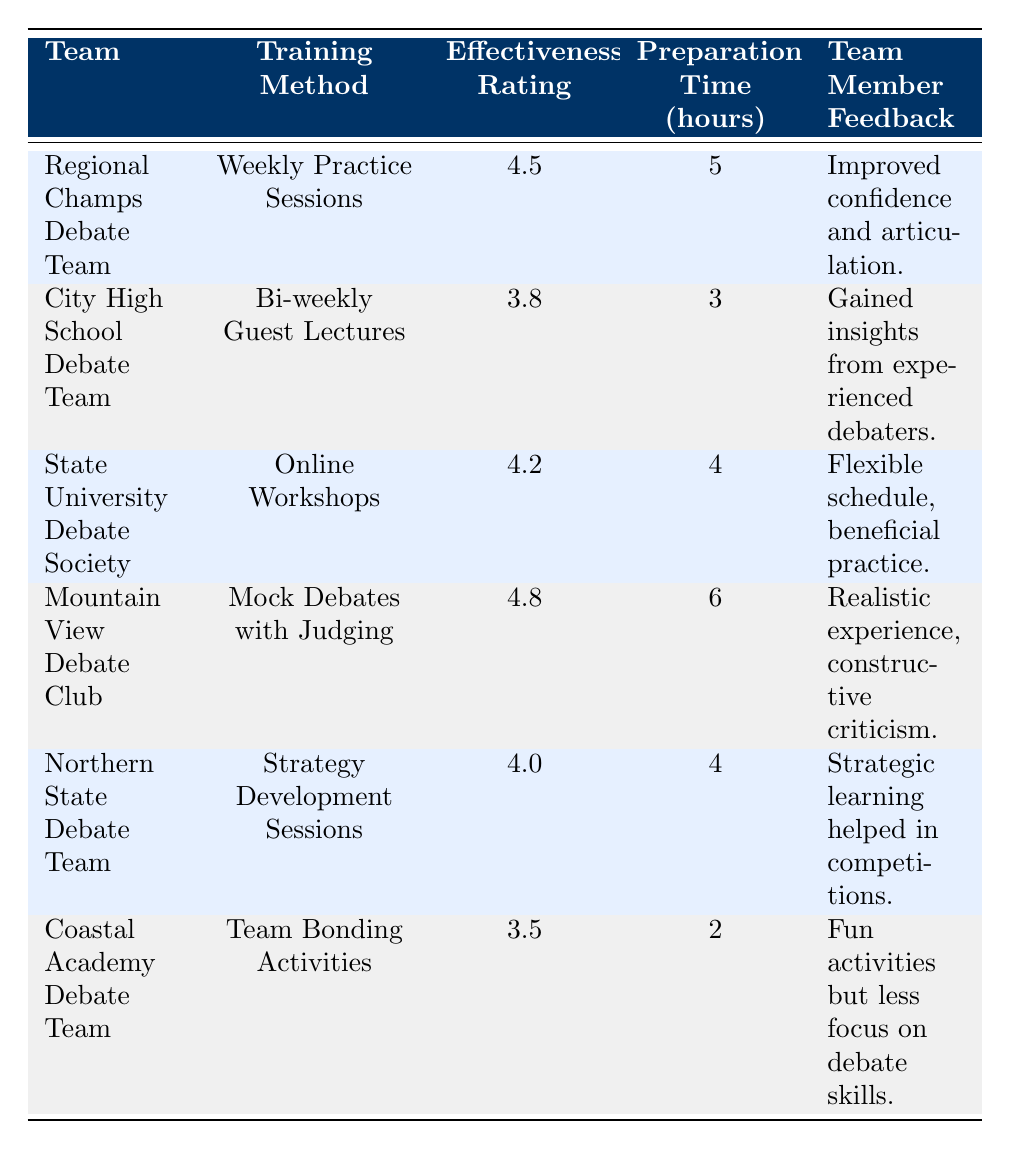What is the effectiveness rating for the Regional Champs Debate Team? The effectiveness rating for the Regional Champs Debate Team is listed in the table under the relevant column. It shows 4.5.
Answer: 4.5 Which training method has the highest effectiveness rating? By scanning the effectiveness rating column, I identify that the Mountain View Debate Club has the highest rating of 4.8.
Answer: Mock Debates with Judging What is the average preparation time for all teams? To find the average, I sum up the preparation times (5 + 3 + 4 + 6 + 4 + 2 = 24) and divide by the number of teams (6) giving 24/6 = 4.
Answer: 4 Is the effectiveness rating of the Coastal Academy Debate Team greater than 4? The effectiveness rating for the Coastal Academy Debate Team is 3.5, which is less than 4; thus, the statement is false.
Answer: No What feedback did the State University Debate Society receive? The table provides the feedback for the State University Debate Society as "Flexible schedule, beneficial practice."
Answer: Flexible schedule, beneficial practice Which team's training method involved community members? The City High School Debate Team's training method involved community members through bi-weekly guest lectures from experienced debaters, fostering community involvement.
Answer: Bi-weekly Guest Lectures How many teams have a preparation time of 4 hours or more? A review of the preparation time shows that three teams (Regional Champs, State University, and Mountain View Debate Club) have 4 hours or more.
Answer: 3 Was the feedback for the Northern State Debate Team positive? The feedback, stating "Strategic learning helped in competitions," indicates a positive response, confirming that the feedback for this team was indeed positive.
Answer: Yes What is the difference in effectiveness ratings between the Mountain View Debate Club and the Coastal Academy Debate Team? The effectiveness rating for Mountain View is 4.8, while for Coastal Academy it is 3.5. The difference is calculated as 4.8 - 3.5 = 1.3.
Answer: 1.3 